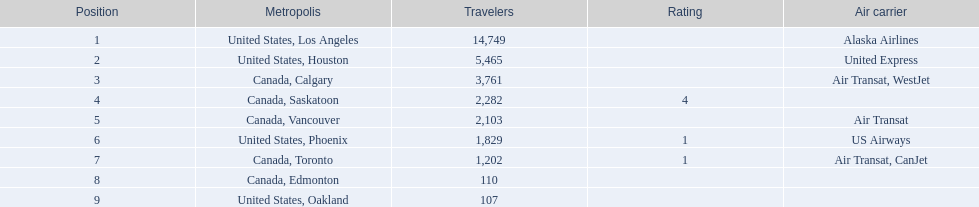What were all the passenger totals? 14,749, 5,465, 3,761, 2,282, 2,103, 1,829, 1,202, 110, 107. Which of these were to los angeles? 14,749. What other destination combined with this is closest to 19,000? Canada, Calgary. 